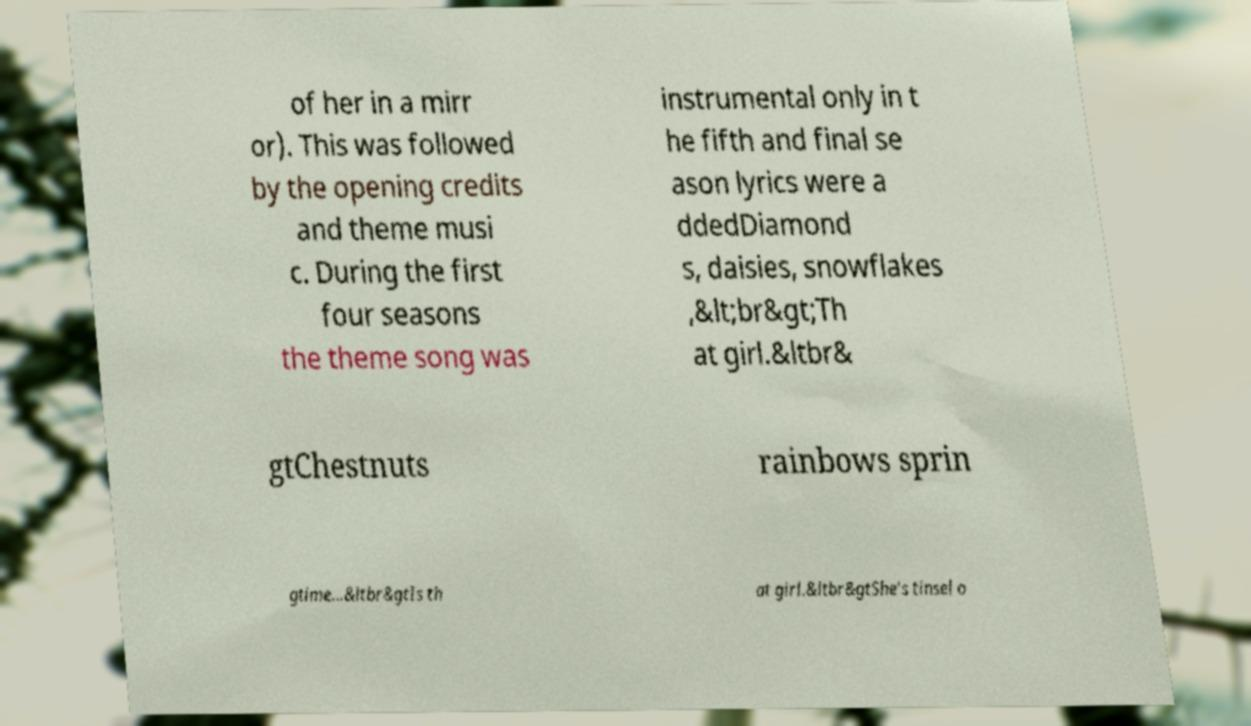What messages or text are displayed in this image? I need them in a readable, typed format. of her in a mirr or). This was followed by the opening credits and theme musi c. During the first four seasons the theme song was instrumental only in t he fifth and final se ason lyrics were a ddedDiamond s, daisies, snowflakes ,&lt;br&gt;Th at girl.&ltbr& gtChestnuts rainbows sprin gtime...&ltbr&gtIs th at girl.&ltbr&gtShe's tinsel o 